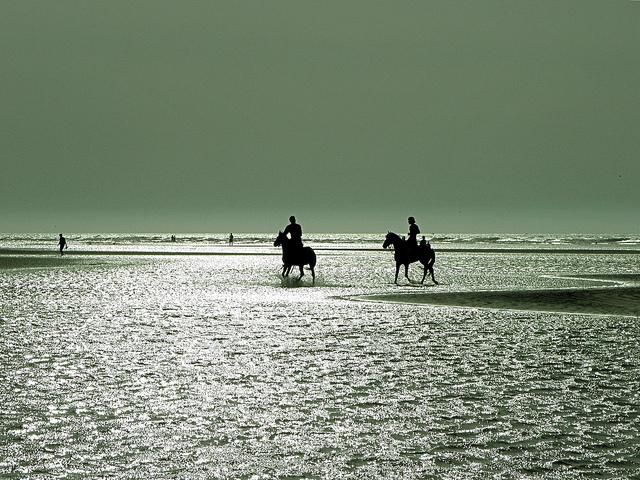How many people aren't riding horses in this picture?
Answer briefly. 3. What is reflecting on the water?
Give a very brief answer. Sun. Is this saltwater?
Concise answer only. Yes. 